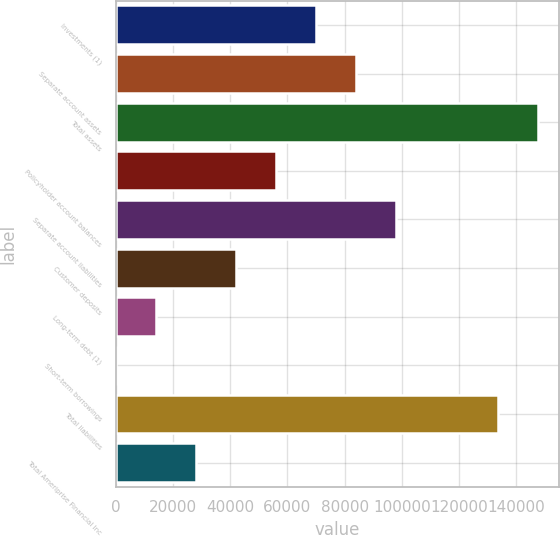Convert chart. <chart><loc_0><loc_0><loc_500><loc_500><bar_chart><fcel>Investments (1)<fcel>Separate account assets<fcel>Total assets<fcel>Policyholder account balances<fcel>Separate account liabilities<fcel>Customer deposits<fcel>Long-term debt (1)<fcel>Short-term borrowings<fcel>Total liabilities<fcel>Total Ameriprise Financial Inc<nl><fcel>70010.5<fcel>83972.6<fcel>147491<fcel>56048.4<fcel>97934.7<fcel>42086.3<fcel>14162.1<fcel>200<fcel>133529<fcel>28124.2<nl></chart> 